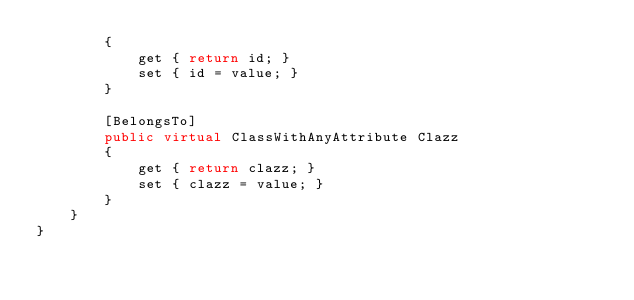<code> <loc_0><loc_0><loc_500><loc_500><_C#_>        {
            get { return id; }
            set { id = value; }
        }

        [BelongsTo]
        public virtual ClassWithAnyAttribute Clazz
        {
            get { return clazz; }
            set { clazz = value; }
        }
    }
}
</code> 